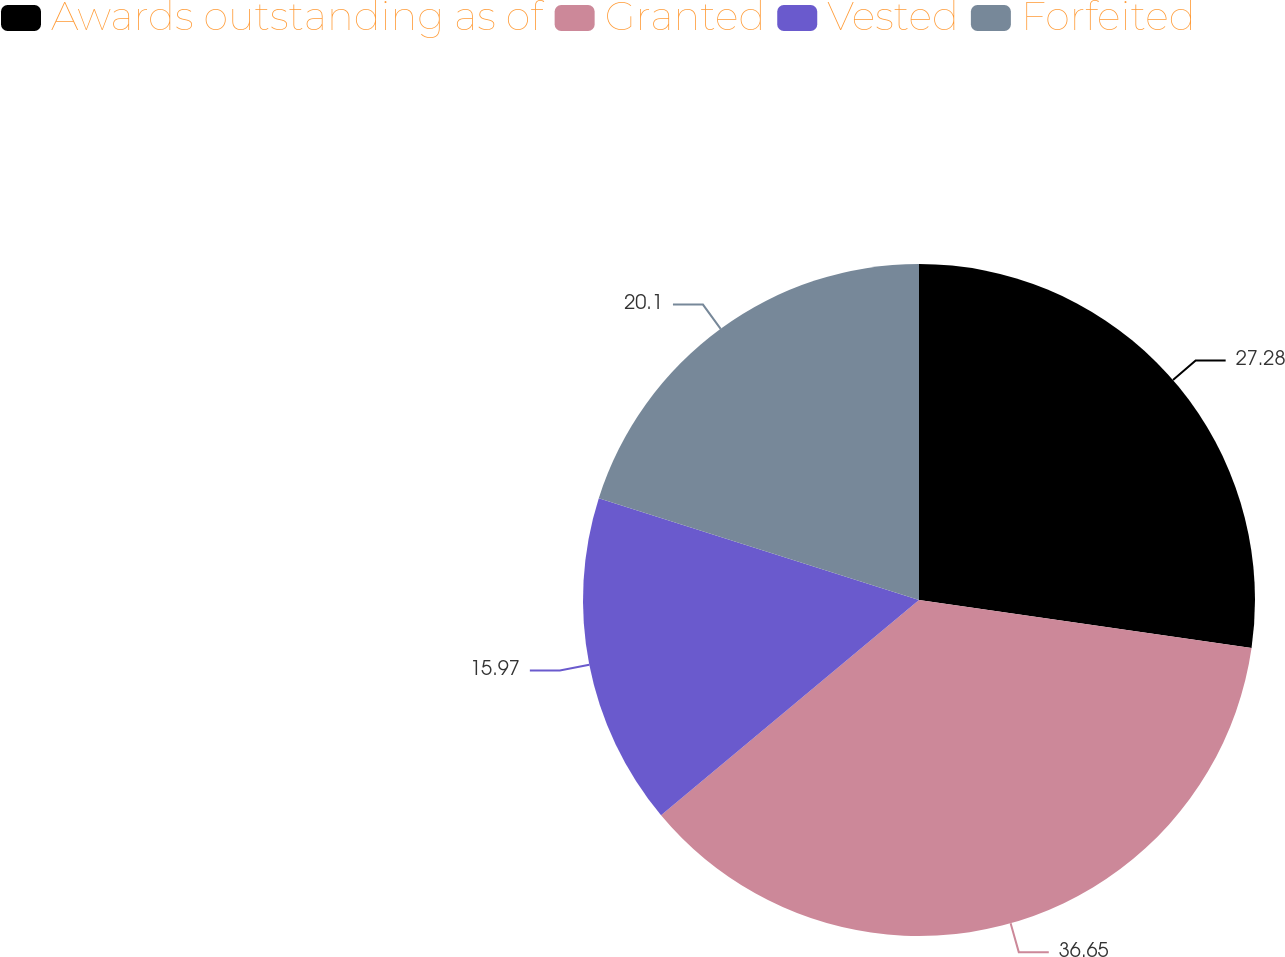Convert chart to OTSL. <chart><loc_0><loc_0><loc_500><loc_500><pie_chart><fcel>Awards outstanding as of<fcel>Granted<fcel>Vested<fcel>Forfeited<nl><fcel>27.28%<fcel>36.65%<fcel>15.97%<fcel>20.1%<nl></chart> 